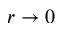Convert formula to latex. <formula><loc_0><loc_0><loc_500><loc_500>r \to 0</formula> 